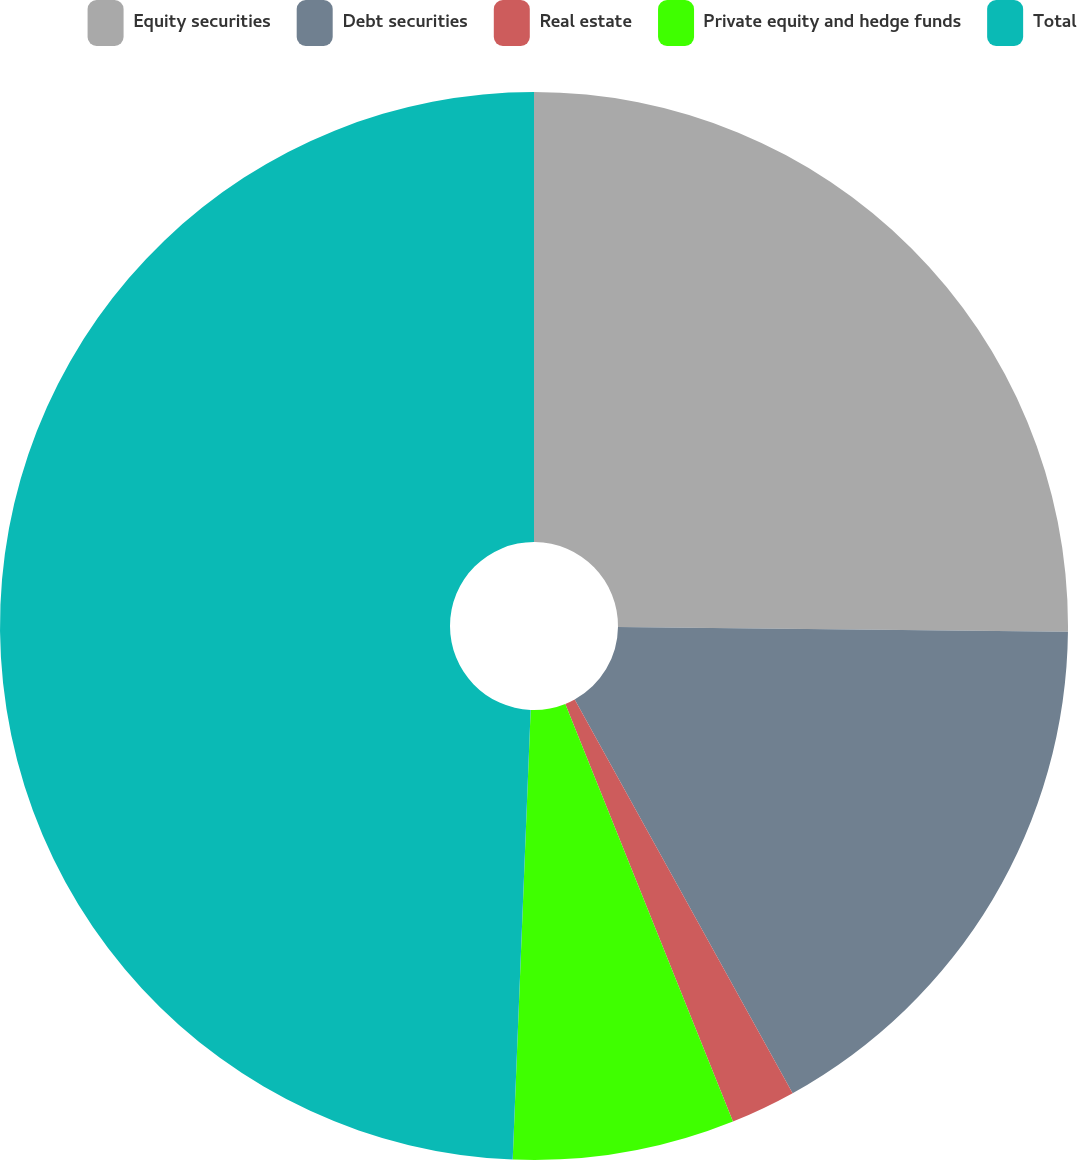Convert chart to OTSL. <chart><loc_0><loc_0><loc_500><loc_500><pie_chart><fcel>Equity securities<fcel>Debt securities<fcel>Real estate<fcel>Private equity and hedge funds<fcel>Total<nl><fcel>25.17%<fcel>16.78%<fcel>1.97%<fcel>6.71%<fcel>49.36%<nl></chart> 